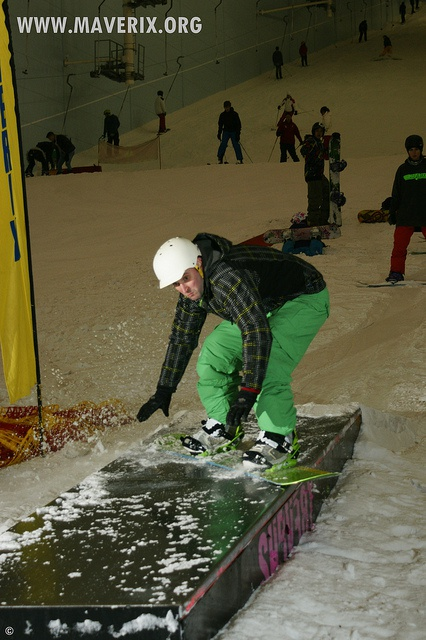Describe the objects in this image and their specific colors. I can see people in olive, black, darkgreen, green, and gray tones, snowboard in olive, darkgreen, gray, and darkgray tones, people in olive, black, and darkgreen tones, snowboard in olive, black, and darkgreen tones, and people in black, darkgreen, and olive tones in this image. 